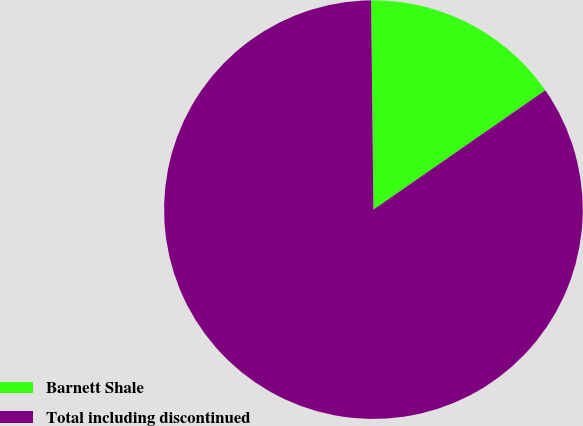<chart> <loc_0><loc_0><loc_500><loc_500><pie_chart><fcel>Barnett Shale<fcel>Total including discontinued<nl><fcel>15.52%<fcel>84.48%<nl></chart> 